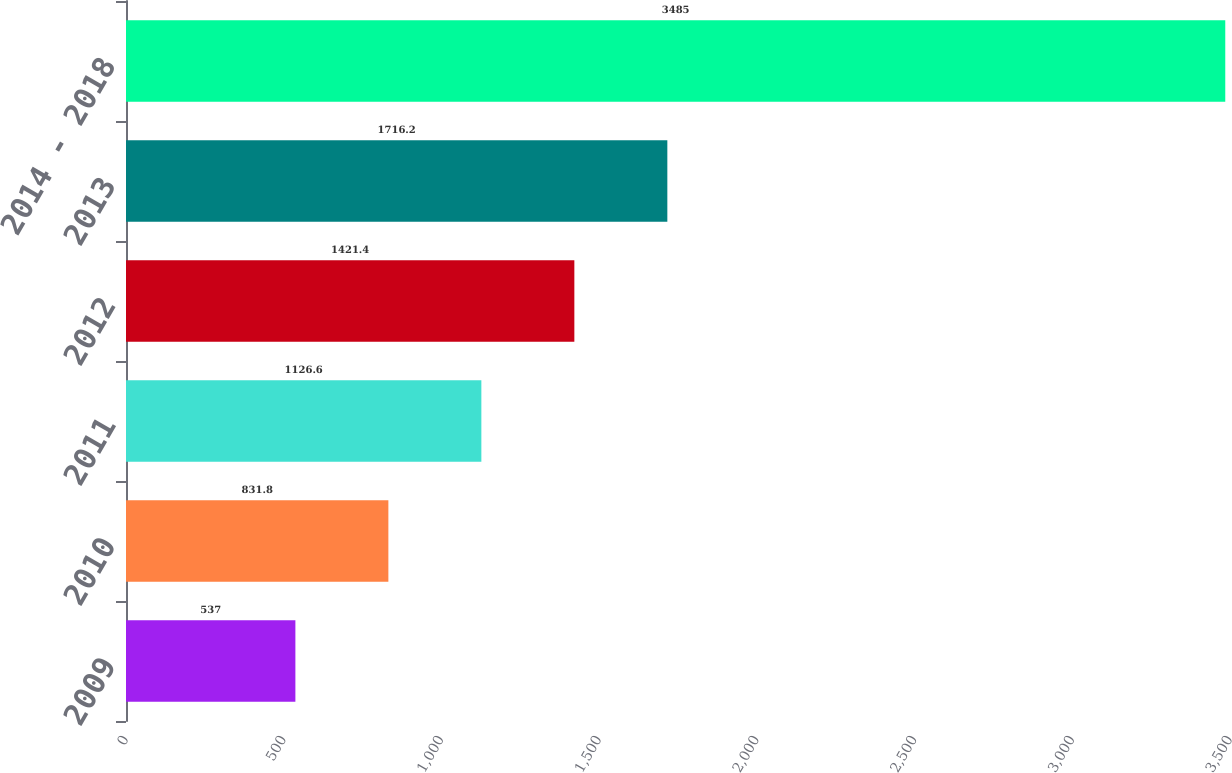<chart> <loc_0><loc_0><loc_500><loc_500><bar_chart><fcel>2009<fcel>2010<fcel>2011<fcel>2012<fcel>2013<fcel>2014 - 2018<nl><fcel>537<fcel>831.8<fcel>1126.6<fcel>1421.4<fcel>1716.2<fcel>3485<nl></chart> 